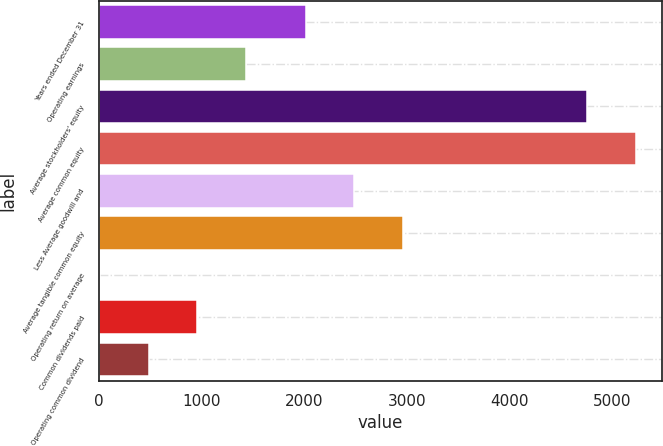Convert chart to OTSL. <chart><loc_0><loc_0><loc_500><loc_500><bar_chart><fcel>Years ended December 31<fcel>Operating earnings<fcel>Average stockholders' equity<fcel>Average common equity<fcel>Less Average goodwill and<fcel>Average tangible common equity<fcel>Operating return on average<fcel>Common dividends paid<fcel>Operating common dividend<nl><fcel>2013<fcel>1432.94<fcel>4755<fcel>5229.58<fcel>2487.58<fcel>2962.16<fcel>9.2<fcel>958.36<fcel>483.78<nl></chart> 